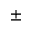<formula> <loc_0><loc_0><loc_500><loc_500>\pm</formula> 